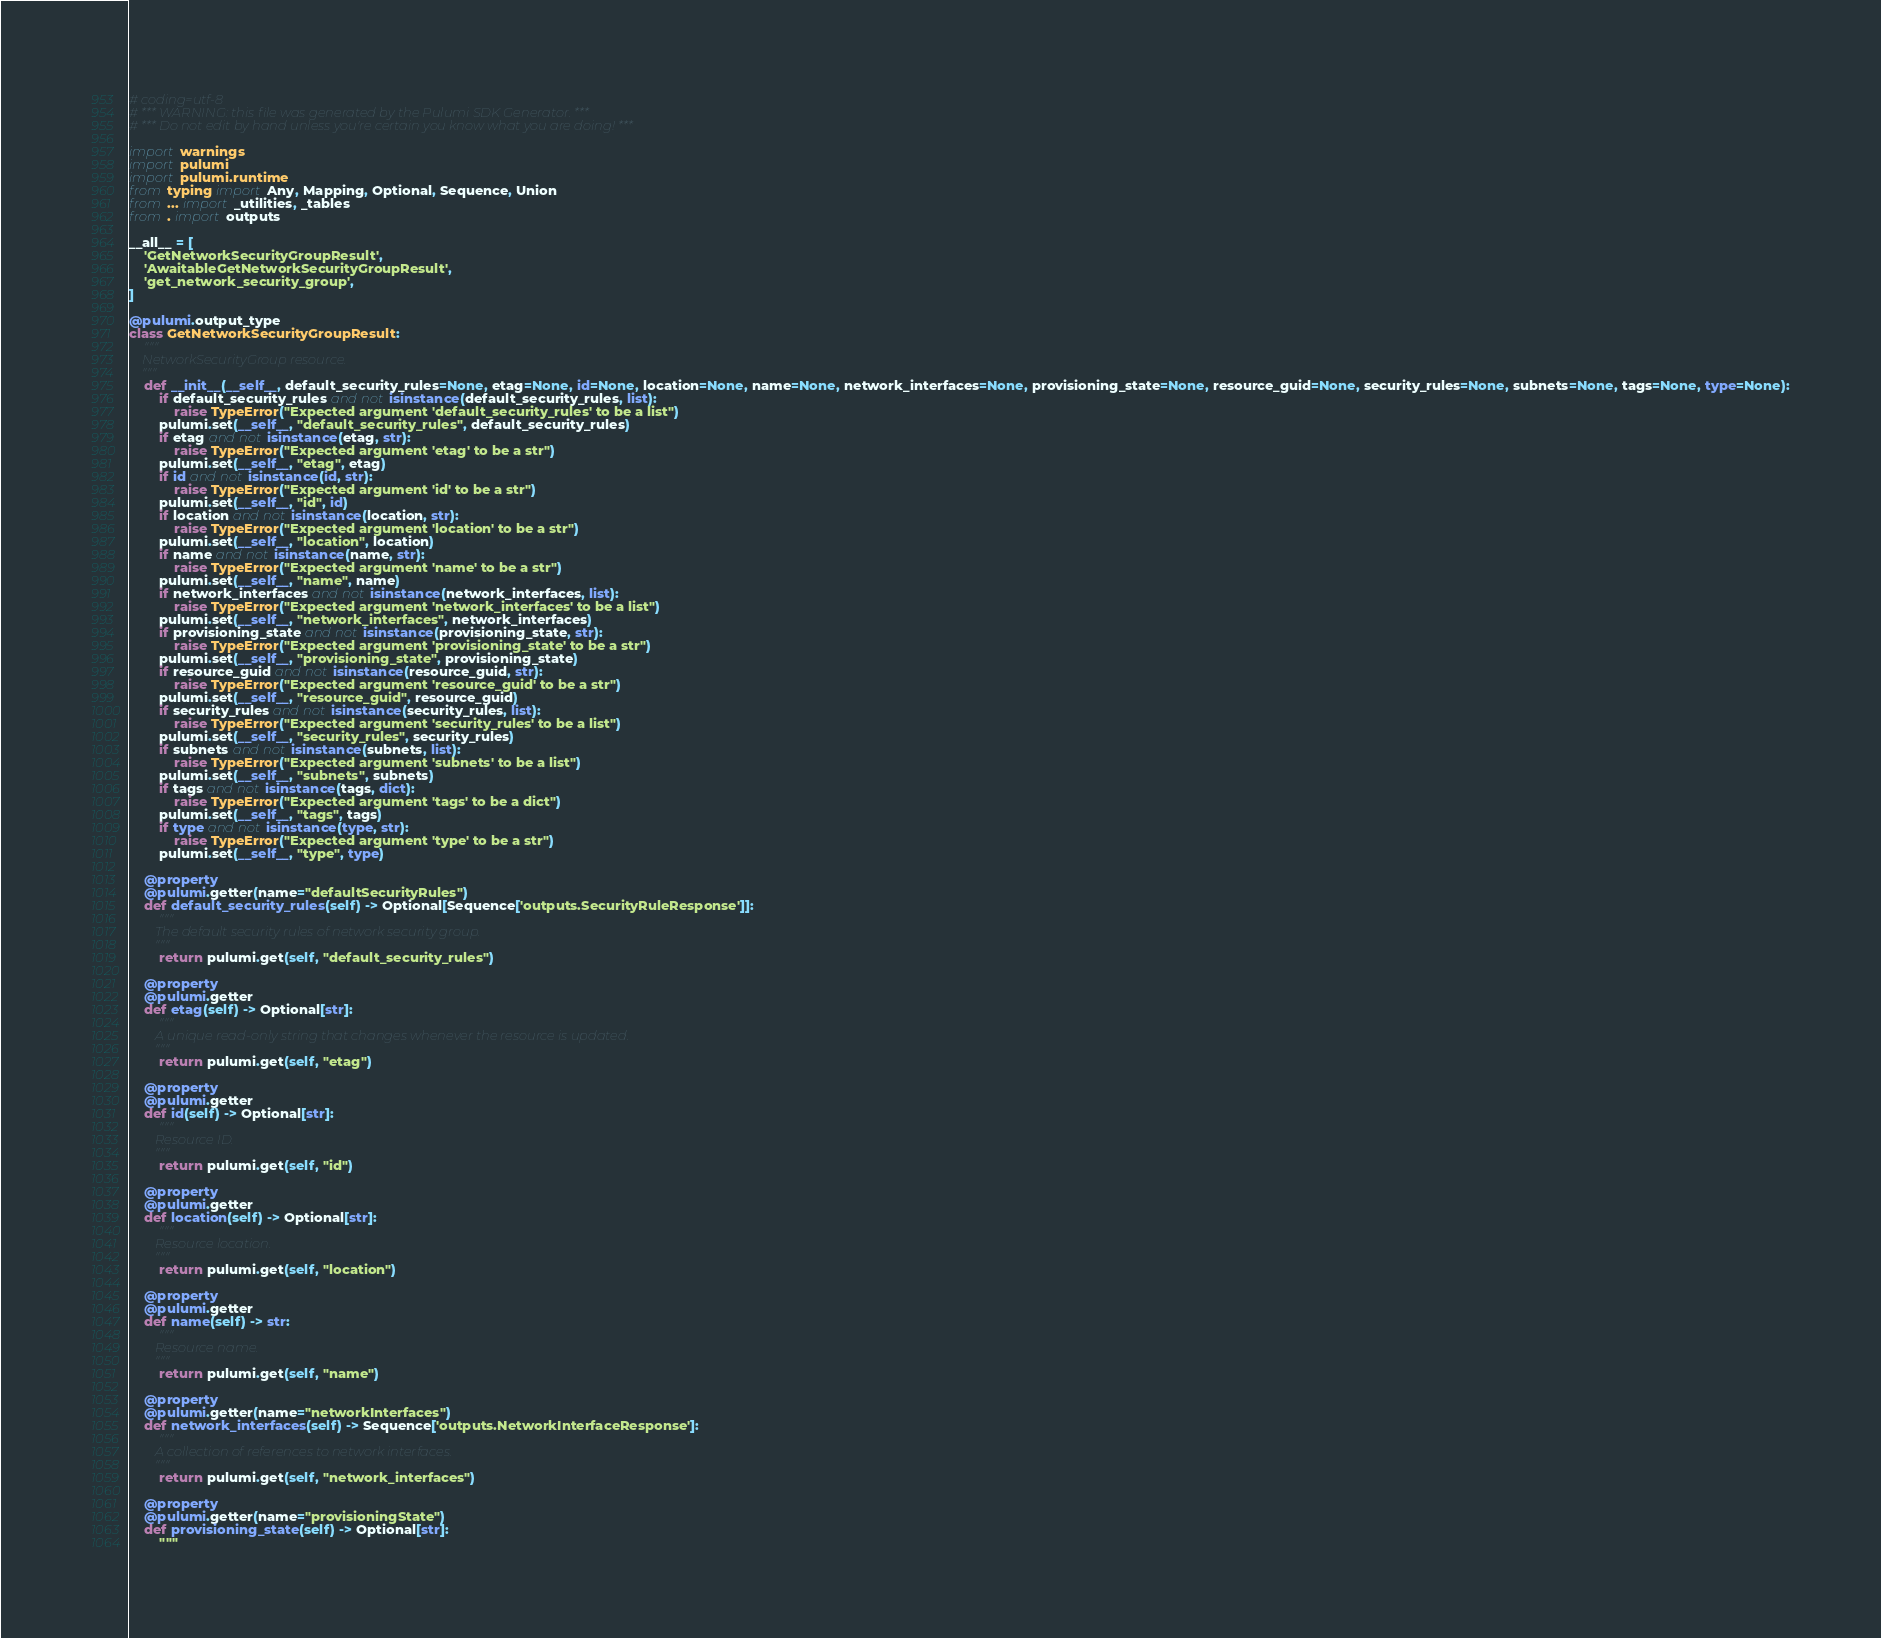<code> <loc_0><loc_0><loc_500><loc_500><_Python_># coding=utf-8
# *** WARNING: this file was generated by the Pulumi SDK Generator. ***
# *** Do not edit by hand unless you're certain you know what you are doing! ***

import warnings
import pulumi
import pulumi.runtime
from typing import Any, Mapping, Optional, Sequence, Union
from ... import _utilities, _tables
from . import outputs

__all__ = [
    'GetNetworkSecurityGroupResult',
    'AwaitableGetNetworkSecurityGroupResult',
    'get_network_security_group',
]

@pulumi.output_type
class GetNetworkSecurityGroupResult:
    """
    NetworkSecurityGroup resource.
    """
    def __init__(__self__, default_security_rules=None, etag=None, id=None, location=None, name=None, network_interfaces=None, provisioning_state=None, resource_guid=None, security_rules=None, subnets=None, tags=None, type=None):
        if default_security_rules and not isinstance(default_security_rules, list):
            raise TypeError("Expected argument 'default_security_rules' to be a list")
        pulumi.set(__self__, "default_security_rules", default_security_rules)
        if etag and not isinstance(etag, str):
            raise TypeError("Expected argument 'etag' to be a str")
        pulumi.set(__self__, "etag", etag)
        if id and not isinstance(id, str):
            raise TypeError("Expected argument 'id' to be a str")
        pulumi.set(__self__, "id", id)
        if location and not isinstance(location, str):
            raise TypeError("Expected argument 'location' to be a str")
        pulumi.set(__self__, "location", location)
        if name and not isinstance(name, str):
            raise TypeError("Expected argument 'name' to be a str")
        pulumi.set(__self__, "name", name)
        if network_interfaces and not isinstance(network_interfaces, list):
            raise TypeError("Expected argument 'network_interfaces' to be a list")
        pulumi.set(__self__, "network_interfaces", network_interfaces)
        if provisioning_state and not isinstance(provisioning_state, str):
            raise TypeError("Expected argument 'provisioning_state' to be a str")
        pulumi.set(__self__, "provisioning_state", provisioning_state)
        if resource_guid and not isinstance(resource_guid, str):
            raise TypeError("Expected argument 'resource_guid' to be a str")
        pulumi.set(__self__, "resource_guid", resource_guid)
        if security_rules and not isinstance(security_rules, list):
            raise TypeError("Expected argument 'security_rules' to be a list")
        pulumi.set(__self__, "security_rules", security_rules)
        if subnets and not isinstance(subnets, list):
            raise TypeError("Expected argument 'subnets' to be a list")
        pulumi.set(__self__, "subnets", subnets)
        if tags and not isinstance(tags, dict):
            raise TypeError("Expected argument 'tags' to be a dict")
        pulumi.set(__self__, "tags", tags)
        if type and not isinstance(type, str):
            raise TypeError("Expected argument 'type' to be a str")
        pulumi.set(__self__, "type", type)

    @property
    @pulumi.getter(name="defaultSecurityRules")
    def default_security_rules(self) -> Optional[Sequence['outputs.SecurityRuleResponse']]:
        """
        The default security rules of network security group.
        """
        return pulumi.get(self, "default_security_rules")

    @property
    @pulumi.getter
    def etag(self) -> Optional[str]:
        """
        A unique read-only string that changes whenever the resource is updated.
        """
        return pulumi.get(self, "etag")

    @property
    @pulumi.getter
    def id(self) -> Optional[str]:
        """
        Resource ID.
        """
        return pulumi.get(self, "id")

    @property
    @pulumi.getter
    def location(self) -> Optional[str]:
        """
        Resource location.
        """
        return pulumi.get(self, "location")

    @property
    @pulumi.getter
    def name(self) -> str:
        """
        Resource name.
        """
        return pulumi.get(self, "name")

    @property
    @pulumi.getter(name="networkInterfaces")
    def network_interfaces(self) -> Sequence['outputs.NetworkInterfaceResponse']:
        """
        A collection of references to network interfaces.
        """
        return pulumi.get(self, "network_interfaces")

    @property
    @pulumi.getter(name="provisioningState")
    def provisioning_state(self) -> Optional[str]:
        """</code> 